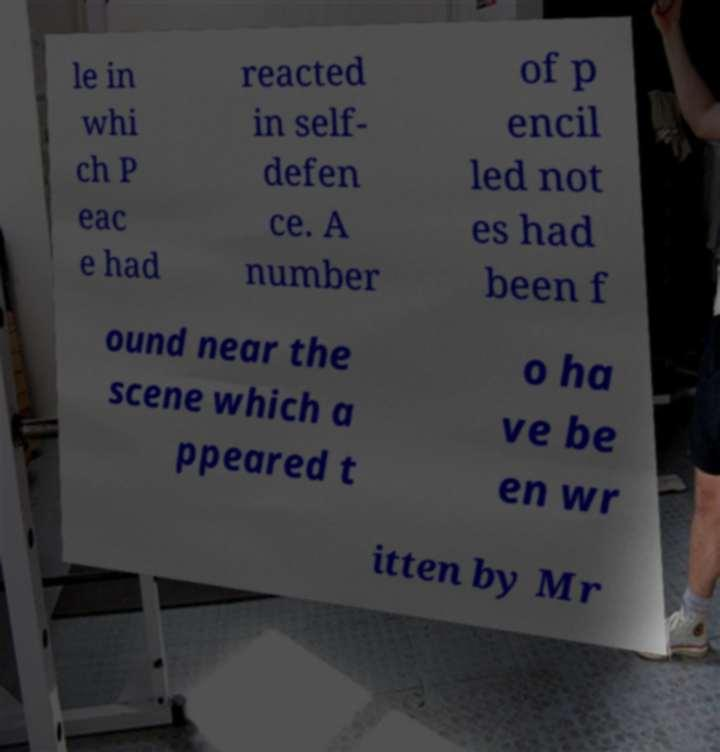There's text embedded in this image that I need extracted. Can you transcribe it verbatim? le in whi ch P eac e had reacted in self- defen ce. A number of p encil led not es had been f ound near the scene which a ppeared t o ha ve be en wr itten by Mr 